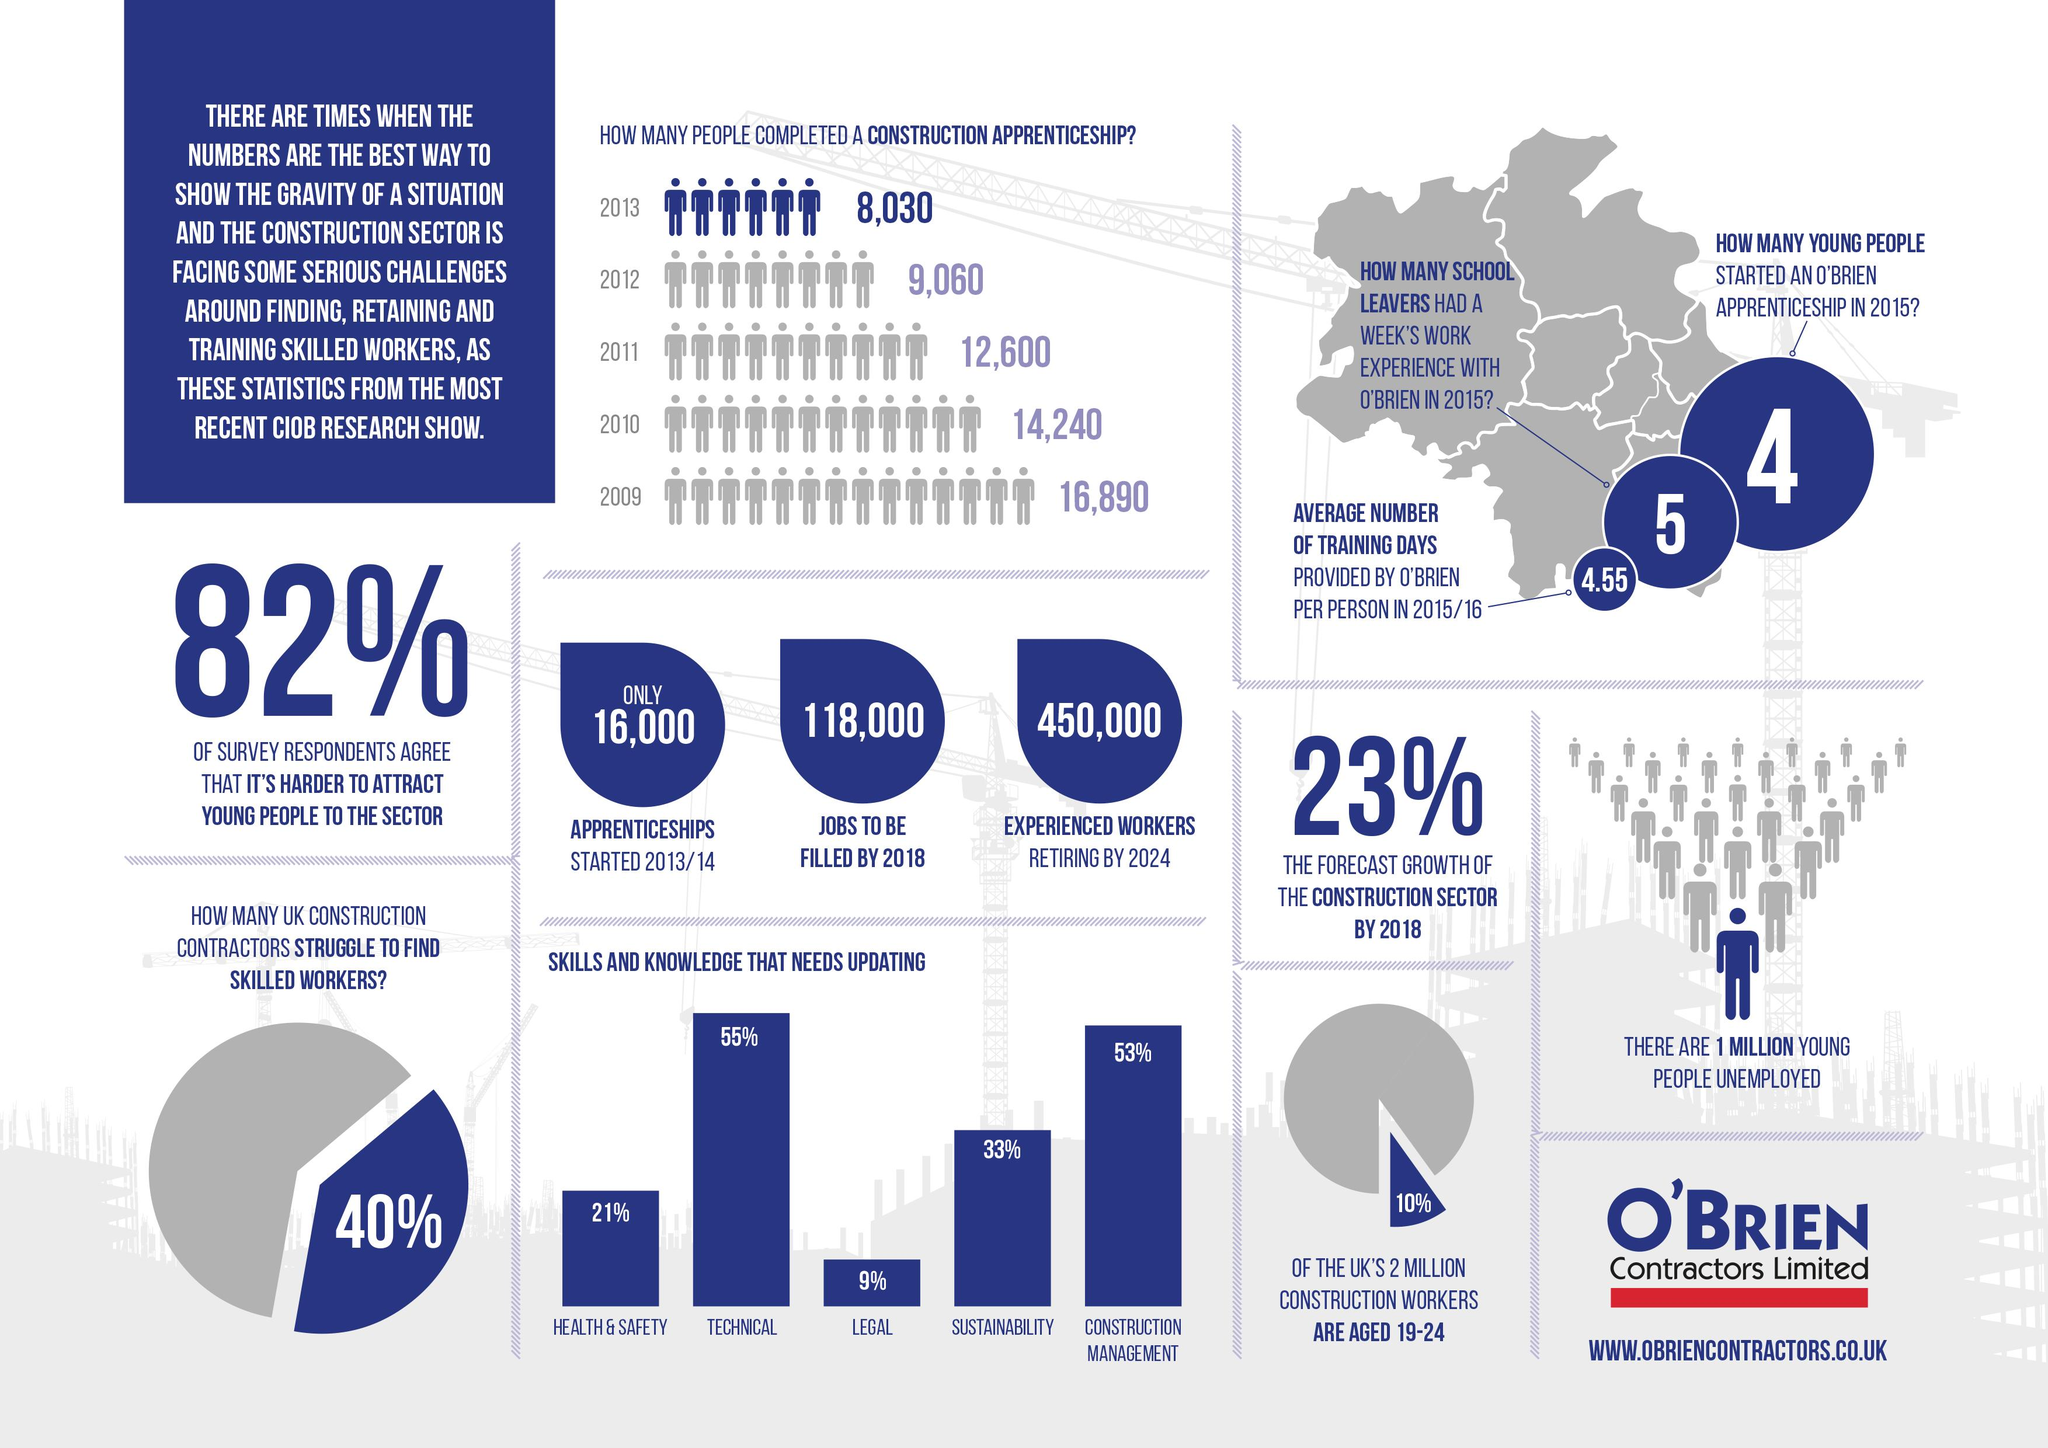List a handful of essential elements in this visual. The second skill and knowledge that requires updating is construction management. It is clear that the most critical skills and knowledge that need to be updated are related to the technical aspects of the job, as they are constantly evolving and changing. The estimated number of experienced workers who will retire in 2024 is approximately 450,000. From 2009 to 2013, there was a significant decrease in the number of people who completed a construction apprenticeship, with an overall decline of 8,860 individuals. 